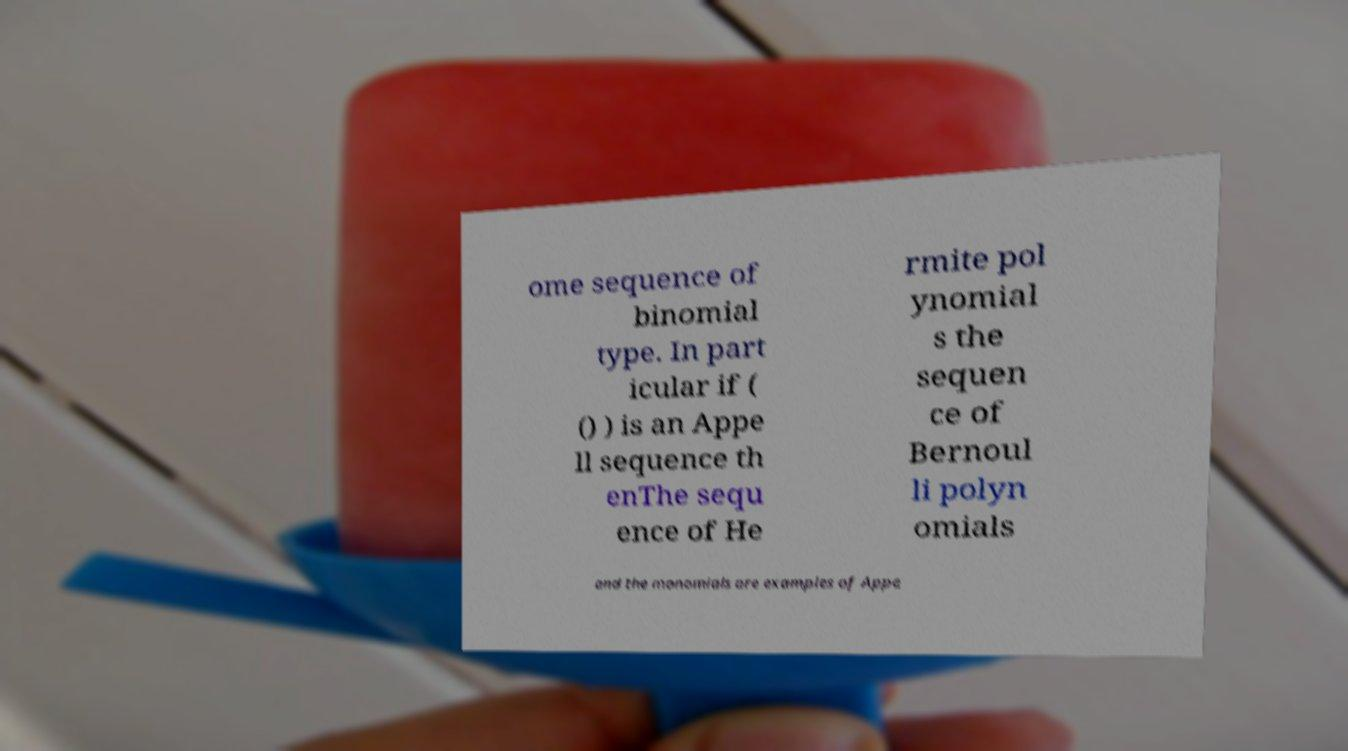Can you accurately transcribe the text from the provided image for me? ome sequence of binomial type. In part icular if ( () ) is an Appe ll sequence th enThe sequ ence of He rmite pol ynomial s the sequen ce of Bernoul li polyn omials and the monomials are examples of Appe 